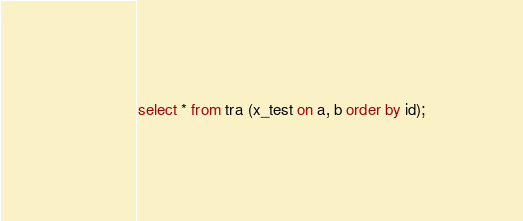Convert code to text. <code><loc_0><loc_0><loc_500><loc_500><_SQL_>select * from tra (x_test on a, b order by id);
</code> 